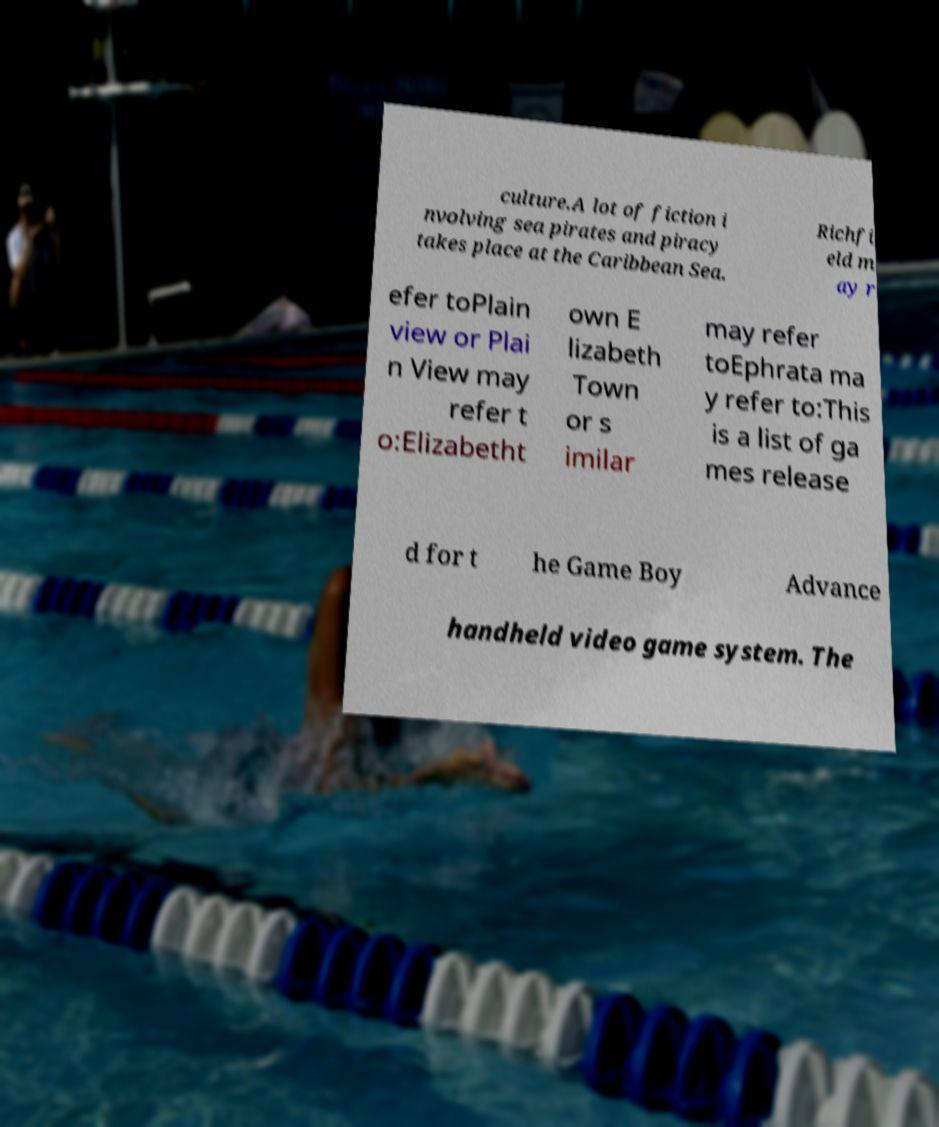What messages or text are displayed in this image? I need them in a readable, typed format. culture.A lot of fiction i nvolving sea pirates and piracy takes place at the Caribbean Sea. Richfi eld m ay r efer toPlain view or Plai n View may refer t o:Elizabetht own E lizabeth Town or s imilar may refer toEphrata ma y refer to:This is a list of ga mes release d for t he Game Boy Advance handheld video game system. The 